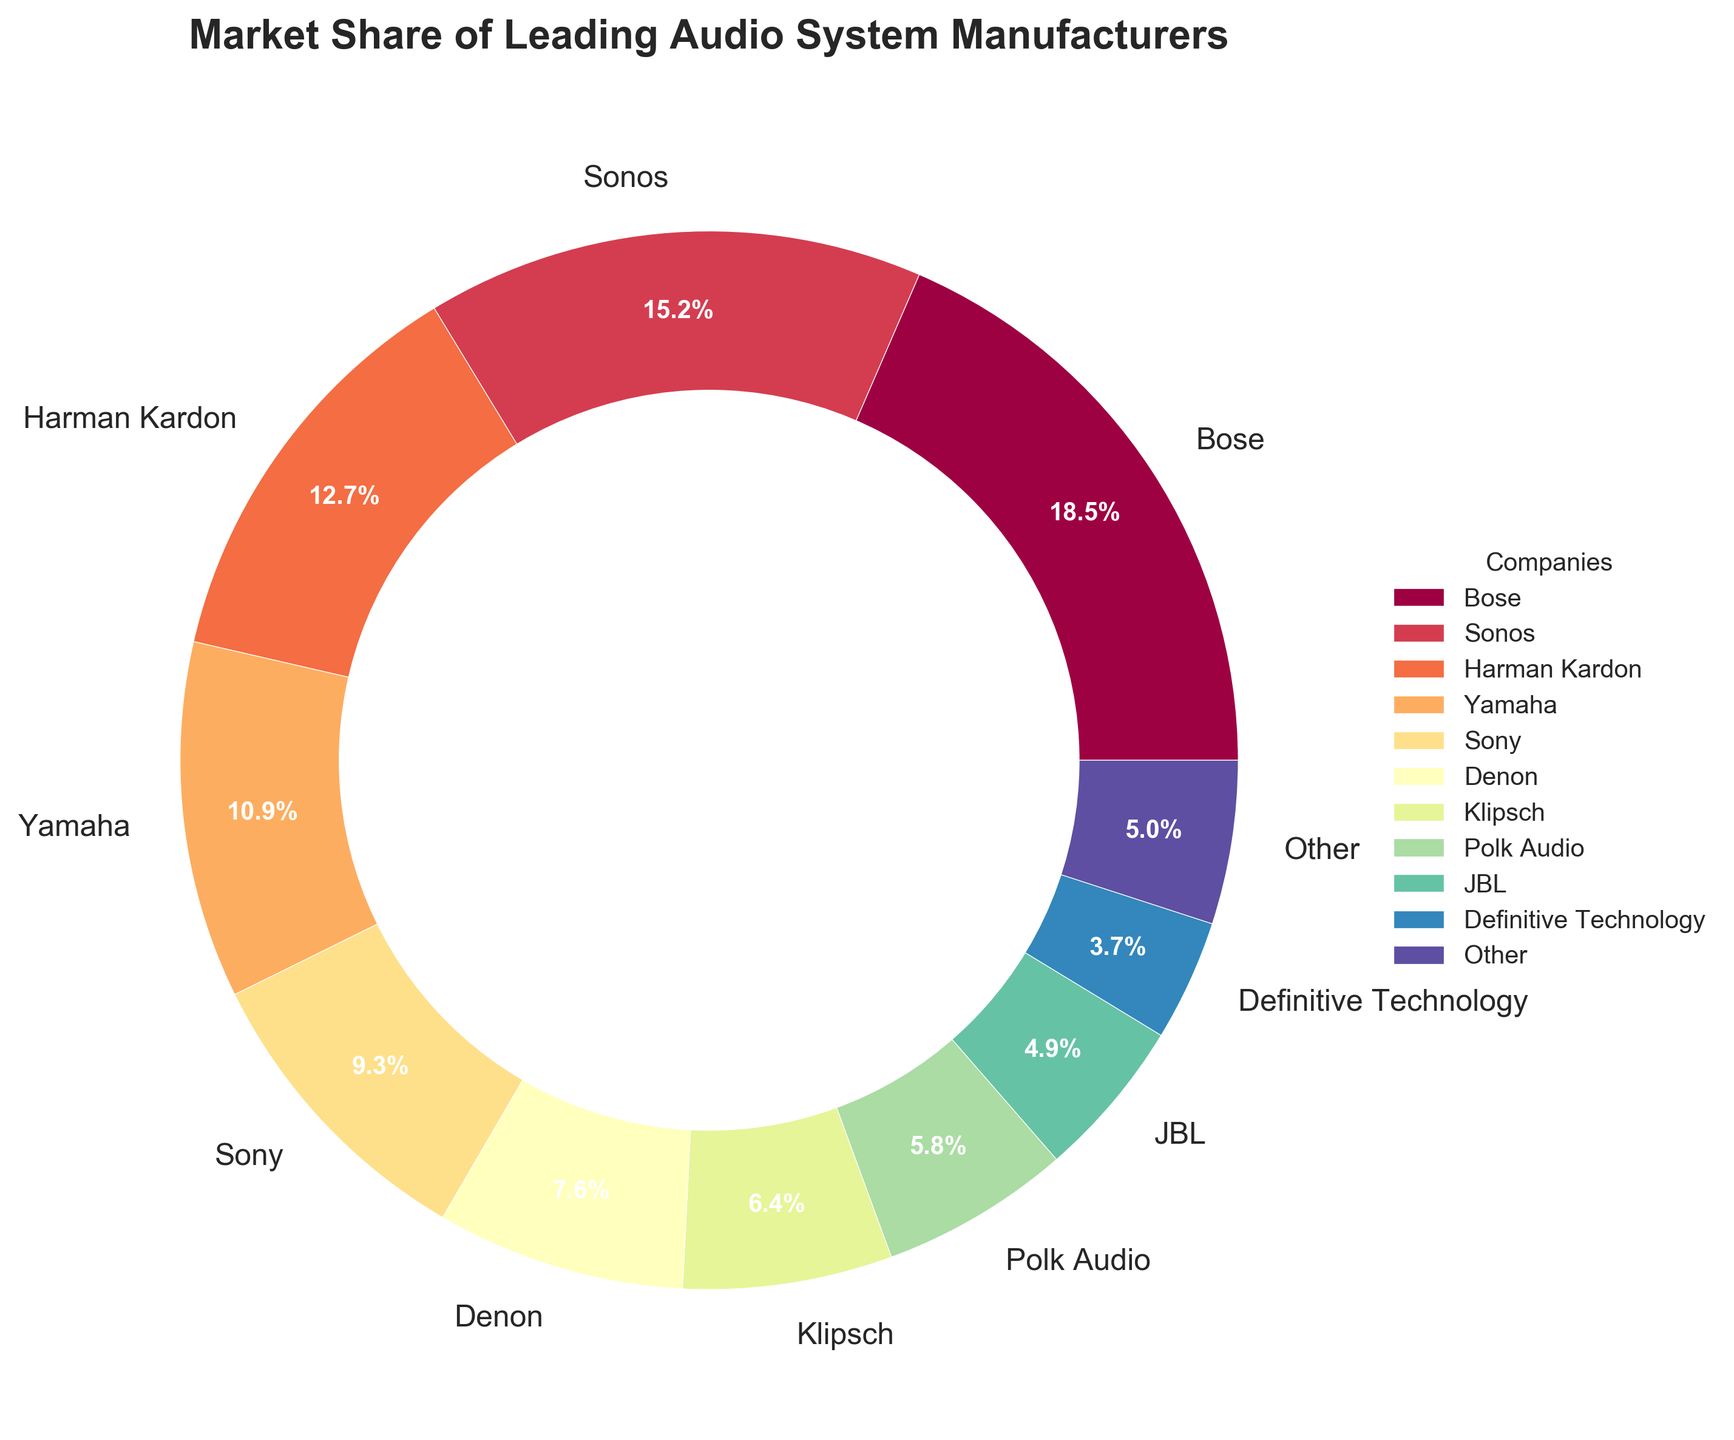Which company has the largest market share? To determine the company with the largest market share, look at the wedges of the pie chart and identify the one that spans the largest angle. The label next to the largest wedge is the company with the largest market share.
Answer: Bose Which two companies have a combined market share closest to 25%? To find two companies with a combined market share close to 25%, sum the market shares of different company pairs and compare them to 25%. Bose (18.5%) and Sony (9.3%) combined give 27.8%, which is quite close. However, Sonos (15.2%) and JBL (4.9%) combine to 20.1%, which is slightly closer.
Answer: Sonos and JBL How does the market share of Harman Kardon compare to that of Denon? Compare the percentages directly, where Harman Kardon has a market share of 12.7% and Denon has a market share of 7.6%. Since 12.7% is greater than 7.6%, Harman Kardon has a larger market share.
Answer: Harman Kardon has a larger market share What's the total market share of companies with less than 10% market share each? Add the market shares of companies with less than 10% market share: Yamaha (10.9% is excluded), Sony (9.3%), Denon (7.6%), Klipsch (6.4%), Polk Audio (5.8%), JBL (4.9%), Definitive Technology (3.7%), and Other (5.0%). Summing 9.3 + 7.6 + 6.4 + 5.8 + 4.9 + 3.7 + 5.0 gives 42.7%.
Answer: 42.7% Which company has a market share closest to the average market share of all companies listed? First, calculate the average market share: Sum all market shares then divide by the number of companies. The sum is 100%, and there are 11 companies, so the average is 100% / 11 = 9.09%. The company with a market share closest to 9.09% is Sony with 9.3%.
Answer: Sony What is the difference in market share between Bose and Polk Audio? Subtract the market share of Polk Audio (5.8%) from Bose (18.5%) to find the difference. 18.5% - 5.8% = 12.7%.
Answer: 12.7% Among Yamaha, Sony, Denon, and Polk Audio, which company has the smallest market share? Compare the market shares: Yamaha (10.9%), Sony (9.3%), Denon (7.6%), and Polk Audio (5.8%). The smallest market share among these is Polk Audio with 5.8%.
Answer: Polk Audio If the market share of 'Other' is to be evenly split among Bose, Sonos, and Harman Kardon, how much will each company’s market share increase? Divide the market share of 'Other' (5.0%) by 3. 5.0% / 3 = 1.67%. Each company will get an additional 1.67%.
Answer: 1.67% Which color represents Sonos in the pie chart? Identify the color used for Sonos by looking at the legend on the chart. The specific color associated with Sonos can be seen in the pie chart’s legend associated with the label "Sonos".
Answer: [The specific color as per visualization] What's the sum of market shares for Denon, Klipsch, and JBL? Add the market shares of Denon (7.6%), Klipsch (6.4%), and JBL (4.9%). Summing 7.6 + 6.4 + 4.9 gives 18.9%.
Answer: 18.9% 